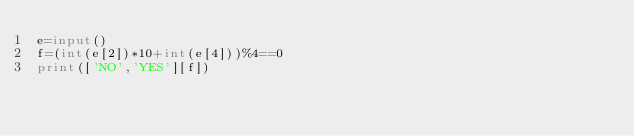<code> <loc_0><loc_0><loc_500><loc_500><_Python_>e=input()
f=(int(e[2])*10+int(e[4]))%4==0
print(['NO','YES'][f])</code> 